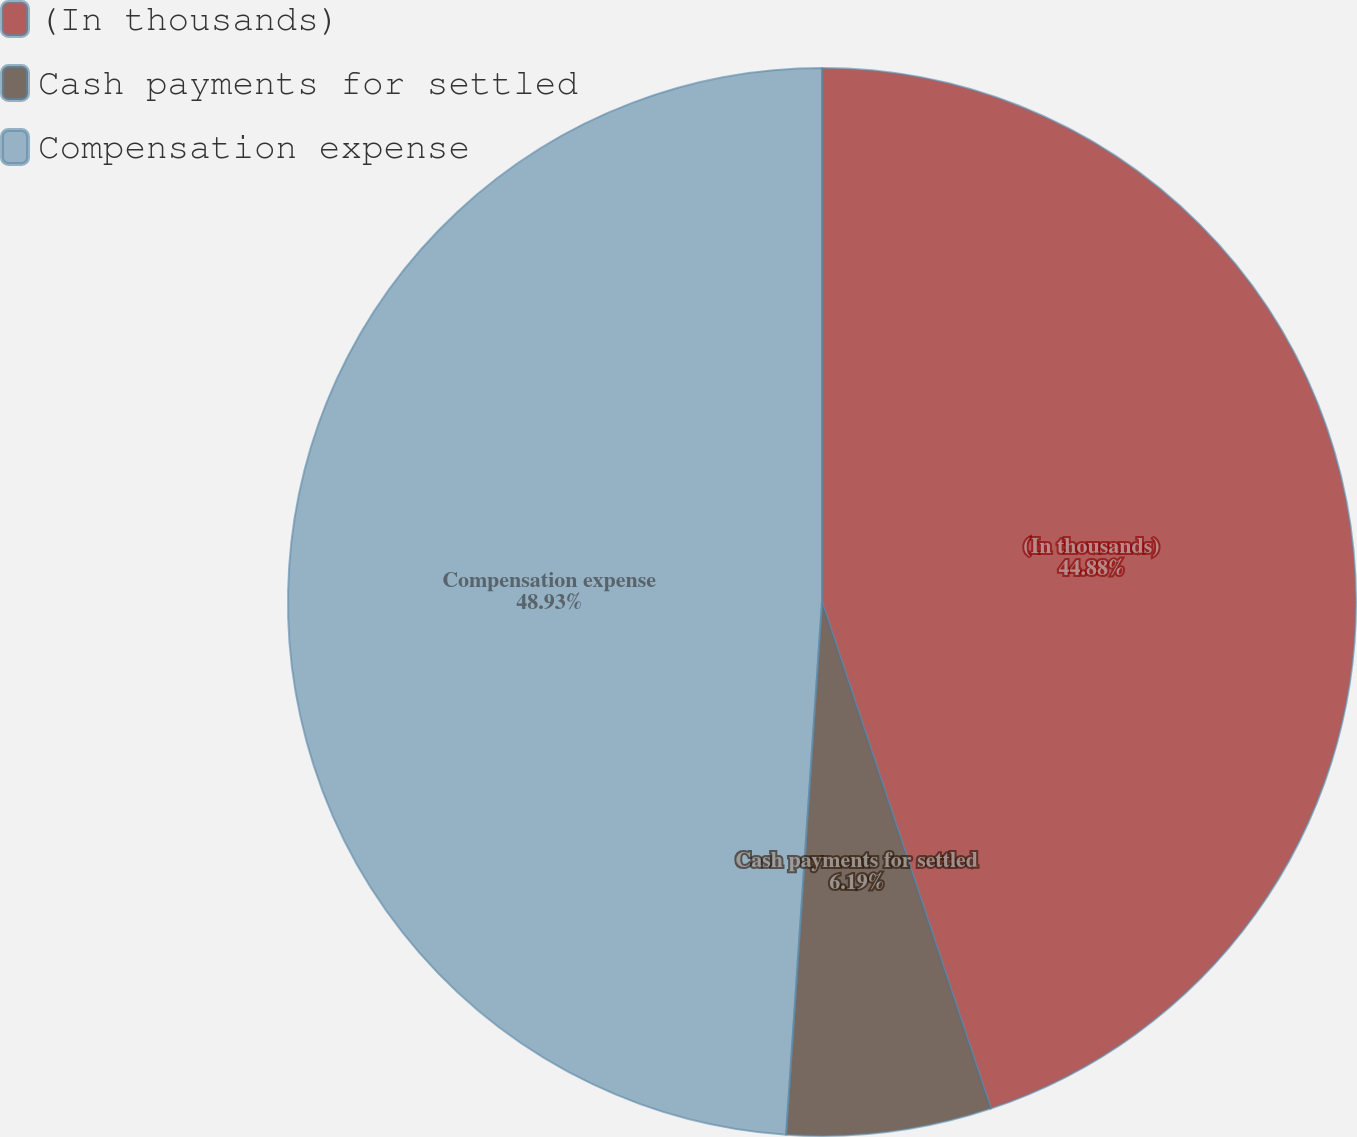<chart> <loc_0><loc_0><loc_500><loc_500><pie_chart><fcel>(In thousands)<fcel>Cash payments for settled<fcel>Compensation expense<nl><fcel>44.88%<fcel>6.19%<fcel>48.93%<nl></chart> 